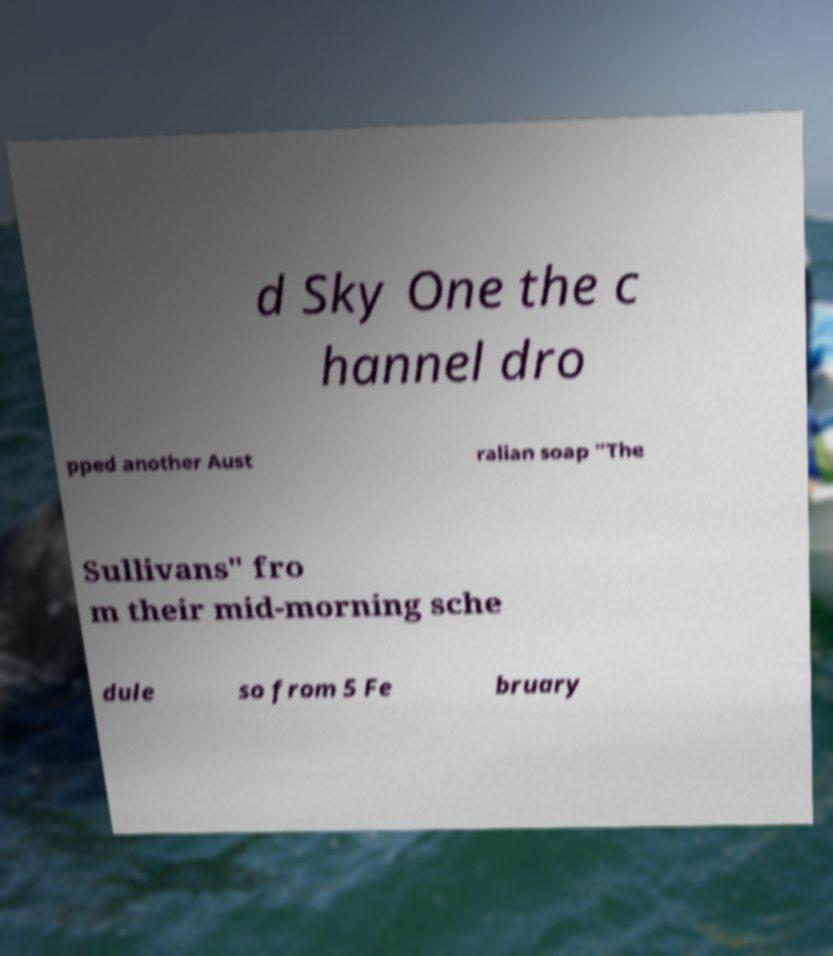Please read and relay the text visible in this image. What does it say? d Sky One the c hannel dro pped another Aust ralian soap "The Sullivans" fro m their mid-morning sche dule so from 5 Fe bruary 